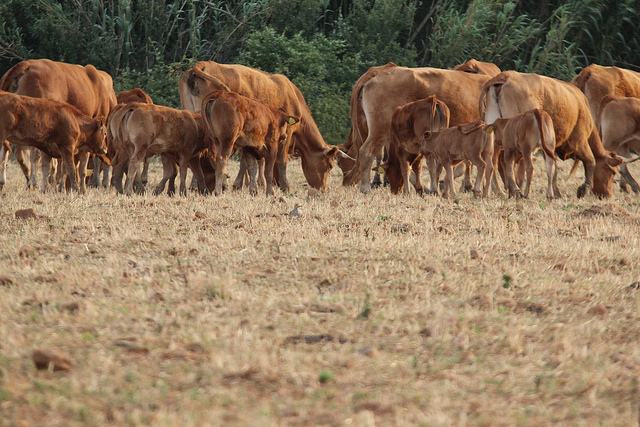What kind of environment do these cows seem to be living in? The cows appear to be living in a pastoral environment, characterized by an open, dried field and surrounded by some greenery, bushes, and trees. The overall scene suggests a peaceful rural setting where cows graze freely. The cows' relaxed demeanor and the presence of natural vegetation in the background indicate that they are likely in a countryside or farmland, accustomed to outdoor life. 